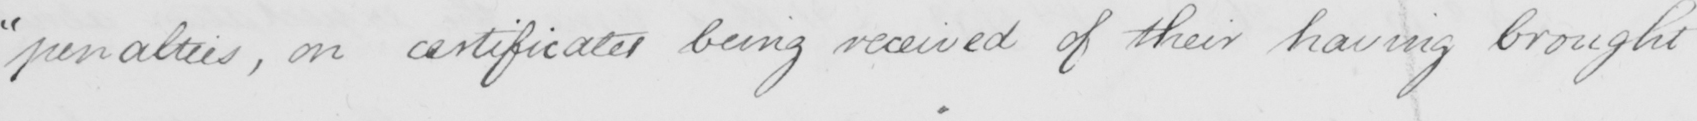What text is written in this handwritten line? " penalties , on certificates being received of their having brought 